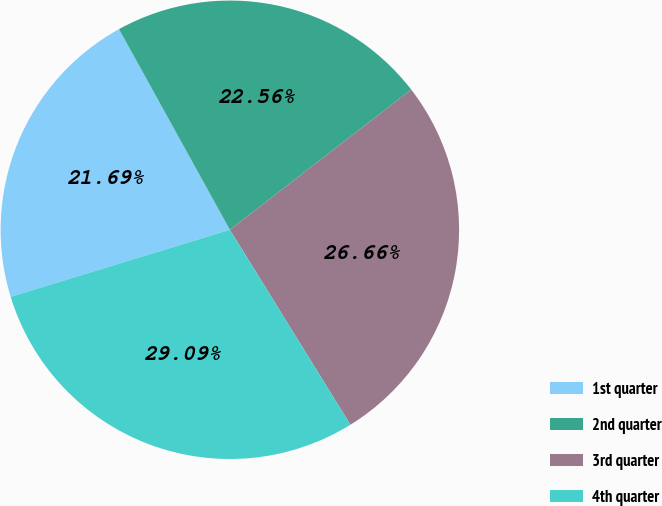Convert chart to OTSL. <chart><loc_0><loc_0><loc_500><loc_500><pie_chart><fcel>1st quarter<fcel>2nd quarter<fcel>3rd quarter<fcel>4th quarter<nl><fcel>21.69%<fcel>22.56%<fcel>26.66%<fcel>29.09%<nl></chart> 